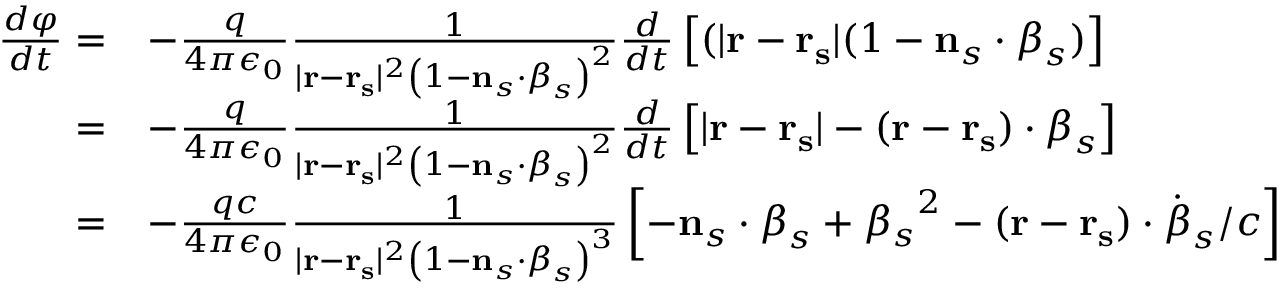Convert formula to latex. <formula><loc_0><loc_0><loc_500><loc_500>{ \begin{array} { r l } { { \frac { d \varphi } { d t } } = } & { - { \frac { q } { 4 \pi \epsilon _ { 0 } } } { \frac { 1 } { | r - r _ { s } | ^ { 2 } \left ( 1 - n _ { s } \cdot { \beta } _ { s } \right ) ^ { 2 } } } { \frac { d } { d t } } \left [ ( | r - r _ { s } | ( 1 - n _ { s } \cdot { \beta } _ { s } ) \right ] } \\ { = } & { - { \frac { q } { 4 \pi \epsilon _ { 0 } } } { \frac { 1 } { | r - r _ { s } | ^ { 2 } \left ( 1 - n _ { s } \cdot { \beta } _ { s } \right ) ^ { 2 } } } { \frac { d } { d t } } \left [ | r - r _ { s } | - ( r - r _ { s } ) \cdot { \beta } _ { s } \right ] } \\ { = } & { - { \frac { q c } { 4 \pi \epsilon _ { 0 } } } { \frac { 1 } { | r - r _ { s } | ^ { 2 } \left ( 1 - n _ { s } \cdot { \beta } _ { s } \right ) ^ { 3 } } } \left [ - n _ { s } \cdot { \beta } _ { s } + { \beta _ { s } } ^ { 2 } - ( r - r _ { s } ) \cdot { \dot { \beta } } _ { s } / c \right ] } \end{array} }</formula> 